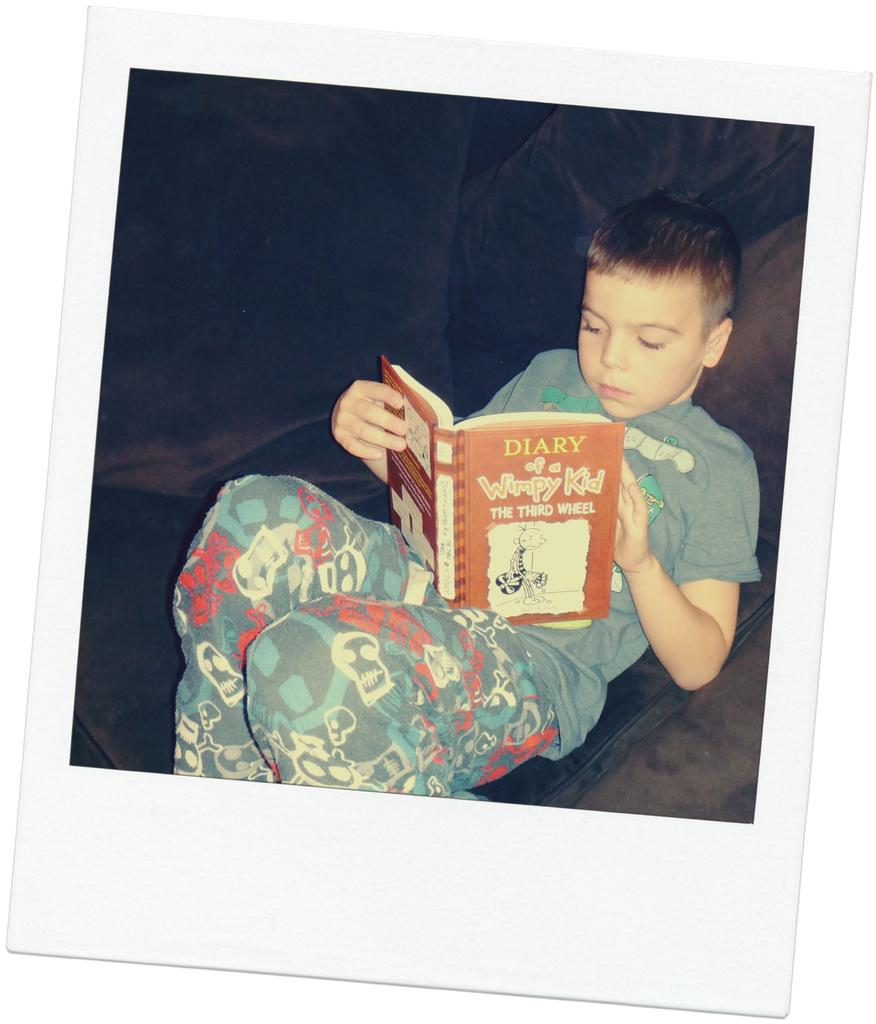<image>
Create a compact narrative representing the image presented. A boy reads A Diary of a Wimpy Kid. 